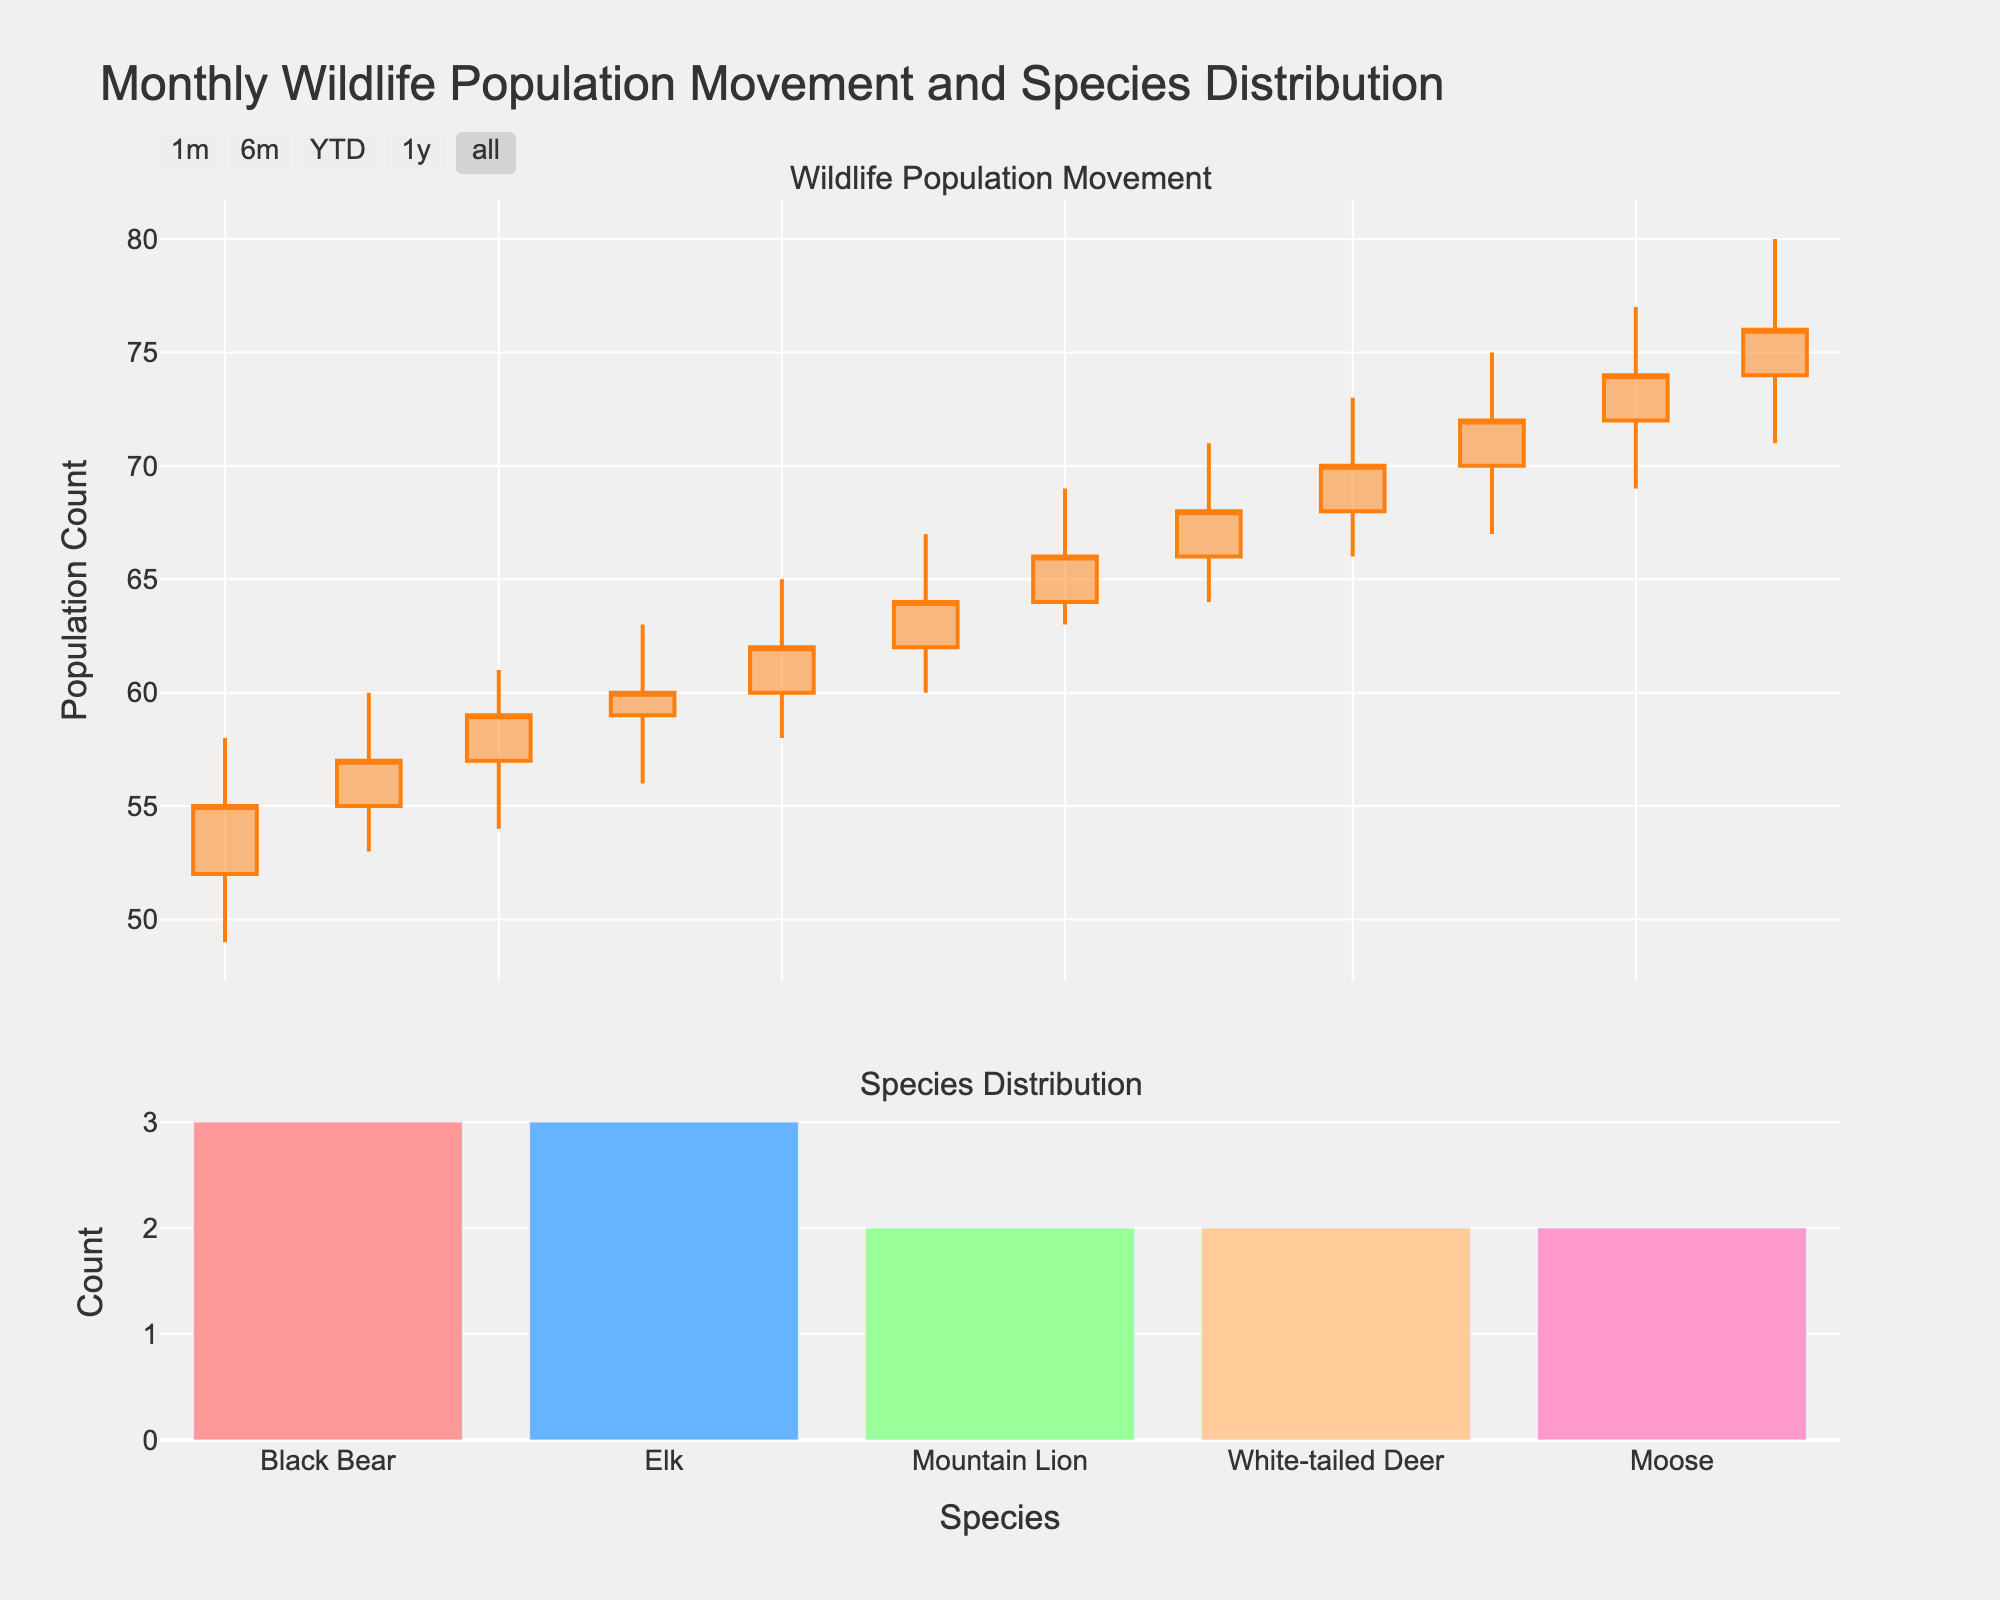What is the title of the figure? The title is displayed prominently at the top of the figure. It provides a summary of what the figure represents.
Answer: Monthly Wildlife Population Movement and Species Distribution What is the highest population count in the candlestick plot? The highest population count corresponds to the highest peak in the candlestick plot's 'High' values. The maximum 'High' value is observed in December, which is 80.
Answer: 80 How many species are tracked in the lower bar chart? The bar chart on the lower part of the figure shows bars corresponding to different species tracked. Each bar represents a species, and there are 5 bars in total.
Answer: 5 Which month has the largest population increase based on the candlestick plot? To determine the largest population increase, compare the difference between the 'Open' and 'Close' values for each month. The largest increase is seen in November, where the population increased from 72 to 74.
Answer: November What is the color of the bars in the species distribution chart? The species distribution bar chart uses a range of colors to distinguish different species. The colors are various shades like pink, blue, green, orange, and pink again.
Answer: Various shades (pink, blue, green, orange, pink) Which species appears the most frequently in the data? Look at the bar chart in the lower subplot, which shows the frequency of each species. The tallest bar corresponds to the Black Bear species.
Answer: Black Bear What is the lowest population count observed in the candlestick plot? The lowest population count corresponds to the lowest trough in the candlestick plot's 'Low' values. The minimum 'Low' value is observed in January, which is 49.
Answer: 49 Between which two months did the population count increase the least, based on the candlestick plot? Calculate the difference between the 'Close' value of one month and the 'Open' value of the next month. The smallest increase is between October and November (72 - 70 = 2).
Answer: October to November Which month shows the most significant decrease in population count? To find the most significant decrease, compare the 'Open' and 'Close' values for each month. In March, the population decreased from 57 to 54, which is the most significant decrease observed.
Answer: March Which national park is associated with the data point for August? Refer to the dataset or the x-axis labels if they include location information. The data point for August is associated with Grand Canyon National Park.
Answer: Grand Canyon National Park 